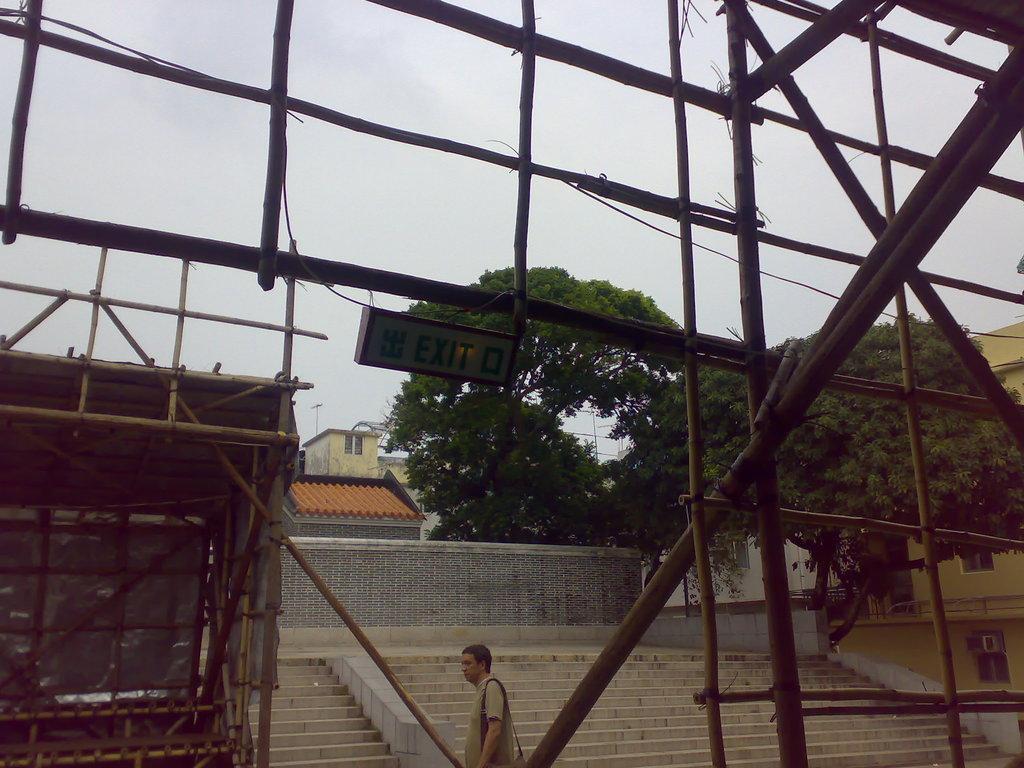Please provide a concise description of this image. There is one man present at the bottom of this image. We can see stairs, buildings and trees in the background and the sky is at the top of this image. 